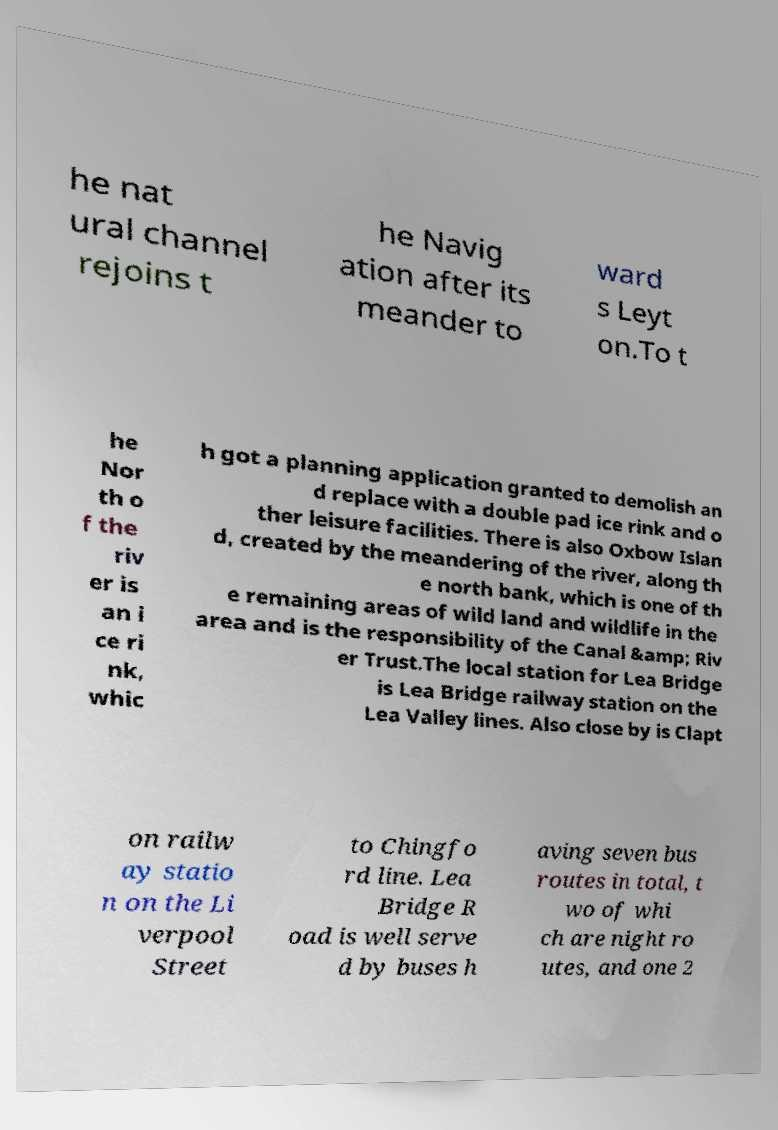For documentation purposes, I need the text within this image transcribed. Could you provide that? he nat ural channel rejoins t he Navig ation after its meander to ward s Leyt on.To t he Nor th o f the riv er is an i ce ri nk, whic h got a planning application granted to demolish an d replace with a double pad ice rink and o ther leisure facilities. There is also Oxbow Islan d, created by the meandering of the river, along th e north bank, which is one of th e remaining areas of wild land and wildlife in the area and is the responsibility of the Canal &amp; Riv er Trust.The local station for Lea Bridge is Lea Bridge railway station on the Lea Valley lines. Also close by is Clapt on railw ay statio n on the Li verpool Street to Chingfo rd line. Lea Bridge R oad is well serve d by buses h aving seven bus routes in total, t wo of whi ch are night ro utes, and one 2 